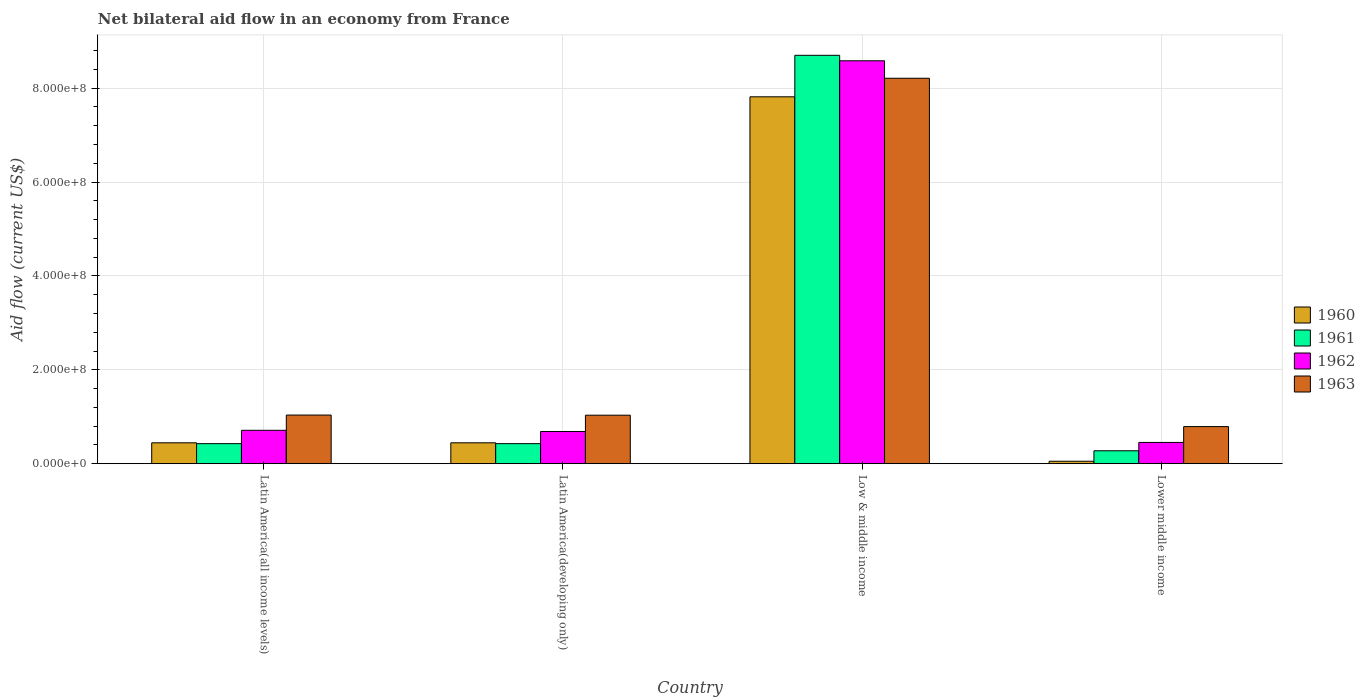How many groups of bars are there?
Provide a succinct answer. 4. Are the number of bars per tick equal to the number of legend labels?
Make the answer very short. Yes. Are the number of bars on each tick of the X-axis equal?
Offer a very short reply. Yes. How many bars are there on the 4th tick from the left?
Ensure brevity in your answer.  4. How many bars are there on the 4th tick from the right?
Your answer should be very brief. 4. What is the label of the 1st group of bars from the left?
Your answer should be very brief. Latin America(all income levels). What is the net bilateral aid flow in 1960 in Latin America(all income levels)?
Provide a short and direct response. 4.46e+07. Across all countries, what is the maximum net bilateral aid flow in 1960?
Your answer should be very brief. 7.82e+08. Across all countries, what is the minimum net bilateral aid flow in 1960?
Give a very brief answer. 5.30e+06. In which country was the net bilateral aid flow in 1961 maximum?
Offer a very short reply. Low & middle income. In which country was the net bilateral aid flow in 1963 minimum?
Your answer should be very brief. Lower middle income. What is the total net bilateral aid flow in 1962 in the graph?
Your answer should be very brief. 1.04e+09. What is the difference between the net bilateral aid flow in 1961 in Latin America(all income levels) and that in Latin America(developing only)?
Give a very brief answer. 0. What is the difference between the net bilateral aid flow in 1961 in Latin America(all income levels) and the net bilateral aid flow in 1960 in Lower middle income?
Your response must be concise. 3.75e+07. What is the average net bilateral aid flow in 1960 per country?
Offer a very short reply. 2.19e+08. What is the difference between the net bilateral aid flow of/in 1963 and net bilateral aid flow of/in 1961 in Low & middle income?
Keep it short and to the point. -4.89e+07. What is the ratio of the net bilateral aid flow in 1960 in Low & middle income to that in Lower middle income?
Your answer should be compact. 147.47. Is the net bilateral aid flow in 1962 in Latin America(developing only) less than that in Lower middle income?
Provide a short and direct response. No. Is the difference between the net bilateral aid flow in 1963 in Latin America(all income levels) and Lower middle income greater than the difference between the net bilateral aid flow in 1961 in Latin America(all income levels) and Lower middle income?
Your answer should be very brief. Yes. What is the difference between the highest and the second highest net bilateral aid flow in 1960?
Provide a short and direct response. 7.37e+08. What is the difference between the highest and the lowest net bilateral aid flow in 1963?
Give a very brief answer. 7.42e+08. Is the sum of the net bilateral aid flow in 1962 in Low & middle income and Lower middle income greater than the maximum net bilateral aid flow in 1963 across all countries?
Provide a short and direct response. Yes. Is it the case that in every country, the sum of the net bilateral aid flow in 1961 and net bilateral aid flow in 1963 is greater than the sum of net bilateral aid flow in 1960 and net bilateral aid flow in 1962?
Provide a short and direct response. Yes. What does the 4th bar from the left in Lower middle income represents?
Offer a very short reply. 1963. What does the 1st bar from the right in Low & middle income represents?
Your response must be concise. 1963. How many bars are there?
Provide a short and direct response. 16. How many countries are there in the graph?
Ensure brevity in your answer.  4. Are the values on the major ticks of Y-axis written in scientific E-notation?
Provide a short and direct response. Yes. Where does the legend appear in the graph?
Ensure brevity in your answer.  Center right. How many legend labels are there?
Your response must be concise. 4. What is the title of the graph?
Your response must be concise. Net bilateral aid flow in an economy from France. What is the label or title of the X-axis?
Keep it short and to the point. Country. What is the Aid flow (current US$) in 1960 in Latin America(all income levels)?
Your response must be concise. 4.46e+07. What is the Aid flow (current US$) of 1961 in Latin America(all income levels)?
Offer a terse response. 4.28e+07. What is the Aid flow (current US$) of 1962 in Latin America(all income levels)?
Your response must be concise. 7.12e+07. What is the Aid flow (current US$) of 1963 in Latin America(all income levels)?
Offer a very short reply. 1.04e+08. What is the Aid flow (current US$) of 1960 in Latin America(developing only)?
Keep it short and to the point. 4.46e+07. What is the Aid flow (current US$) in 1961 in Latin America(developing only)?
Provide a short and direct response. 4.28e+07. What is the Aid flow (current US$) in 1962 in Latin America(developing only)?
Give a very brief answer. 6.87e+07. What is the Aid flow (current US$) in 1963 in Latin America(developing only)?
Give a very brief answer. 1.03e+08. What is the Aid flow (current US$) of 1960 in Low & middle income?
Your answer should be very brief. 7.82e+08. What is the Aid flow (current US$) in 1961 in Low & middle income?
Offer a terse response. 8.70e+08. What is the Aid flow (current US$) of 1962 in Low & middle income?
Give a very brief answer. 8.58e+08. What is the Aid flow (current US$) in 1963 in Low & middle income?
Offer a terse response. 8.21e+08. What is the Aid flow (current US$) of 1960 in Lower middle income?
Offer a very short reply. 5.30e+06. What is the Aid flow (current US$) in 1961 in Lower middle income?
Provide a succinct answer. 2.76e+07. What is the Aid flow (current US$) in 1962 in Lower middle income?
Your response must be concise. 4.54e+07. What is the Aid flow (current US$) in 1963 in Lower middle income?
Your answer should be very brief. 7.91e+07. Across all countries, what is the maximum Aid flow (current US$) of 1960?
Keep it short and to the point. 7.82e+08. Across all countries, what is the maximum Aid flow (current US$) in 1961?
Provide a succinct answer. 8.70e+08. Across all countries, what is the maximum Aid flow (current US$) of 1962?
Ensure brevity in your answer.  8.58e+08. Across all countries, what is the maximum Aid flow (current US$) in 1963?
Keep it short and to the point. 8.21e+08. Across all countries, what is the minimum Aid flow (current US$) of 1960?
Offer a terse response. 5.30e+06. Across all countries, what is the minimum Aid flow (current US$) in 1961?
Ensure brevity in your answer.  2.76e+07. Across all countries, what is the minimum Aid flow (current US$) of 1962?
Your answer should be very brief. 4.54e+07. Across all countries, what is the minimum Aid flow (current US$) of 1963?
Your response must be concise. 7.91e+07. What is the total Aid flow (current US$) of 1960 in the graph?
Make the answer very short. 8.76e+08. What is the total Aid flow (current US$) in 1961 in the graph?
Ensure brevity in your answer.  9.83e+08. What is the total Aid flow (current US$) of 1962 in the graph?
Your answer should be very brief. 1.04e+09. What is the total Aid flow (current US$) in 1963 in the graph?
Your answer should be compact. 1.11e+09. What is the difference between the Aid flow (current US$) of 1962 in Latin America(all income levels) and that in Latin America(developing only)?
Offer a terse response. 2.50e+06. What is the difference between the Aid flow (current US$) of 1963 in Latin America(all income levels) and that in Latin America(developing only)?
Ensure brevity in your answer.  3.00e+05. What is the difference between the Aid flow (current US$) of 1960 in Latin America(all income levels) and that in Low & middle income?
Provide a succinct answer. -7.37e+08. What is the difference between the Aid flow (current US$) of 1961 in Latin America(all income levels) and that in Low & middle income?
Give a very brief answer. -8.27e+08. What is the difference between the Aid flow (current US$) of 1962 in Latin America(all income levels) and that in Low & middle income?
Offer a terse response. -7.87e+08. What is the difference between the Aid flow (current US$) in 1963 in Latin America(all income levels) and that in Low & middle income?
Ensure brevity in your answer.  -7.17e+08. What is the difference between the Aid flow (current US$) of 1960 in Latin America(all income levels) and that in Lower middle income?
Provide a short and direct response. 3.93e+07. What is the difference between the Aid flow (current US$) in 1961 in Latin America(all income levels) and that in Lower middle income?
Ensure brevity in your answer.  1.52e+07. What is the difference between the Aid flow (current US$) in 1962 in Latin America(all income levels) and that in Lower middle income?
Offer a very short reply. 2.58e+07. What is the difference between the Aid flow (current US$) in 1963 in Latin America(all income levels) and that in Lower middle income?
Offer a terse response. 2.46e+07. What is the difference between the Aid flow (current US$) in 1960 in Latin America(developing only) and that in Low & middle income?
Give a very brief answer. -7.37e+08. What is the difference between the Aid flow (current US$) in 1961 in Latin America(developing only) and that in Low & middle income?
Offer a terse response. -8.27e+08. What is the difference between the Aid flow (current US$) in 1962 in Latin America(developing only) and that in Low & middle income?
Make the answer very short. -7.90e+08. What is the difference between the Aid flow (current US$) in 1963 in Latin America(developing only) and that in Low & middle income?
Keep it short and to the point. -7.18e+08. What is the difference between the Aid flow (current US$) of 1960 in Latin America(developing only) and that in Lower middle income?
Give a very brief answer. 3.93e+07. What is the difference between the Aid flow (current US$) in 1961 in Latin America(developing only) and that in Lower middle income?
Ensure brevity in your answer.  1.52e+07. What is the difference between the Aid flow (current US$) of 1962 in Latin America(developing only) and that in Lower middle income?
Your answer should be very brief. 2.33e+07. What is the difference between the Aid flow (current US$) in 1963 in Latin America(developing only) and that in Lower middle income?
Your response must be concise. 2.43e+07. What is the difference between the Aid flow (current US$) in 1960 in Low & middle income and that in Lower middle income?
Make the answer very short. 7.76e+08. What is the difference between the Aid flow (current US$) in 1961 in Low & middle income and that in Lower middle income?
Give a very brief answer. 8.42e+08. What is the difference between the Aid flow (current US$) of 1962 in Low & middle income and that in Lower middle income?
Give a very brief answer. 8.13e+08. What is the difference between the Aid flow (current US$) of 1963 in Low & middle income and that in Lower middle income?
Keep it short and to the point. 7.42e+08. What is the difference between the Aid flow (current US$) of 1960 in Latin America(all income levels) and the Aid flow (current US$) of 1961 in Latin America(developing only)?
Your answer should be compact. 1.80e+06. What is the difference between the Aid flow (current US$) of 1960 in Latin America(all income levels) and the Aid flow (current US$) of 1962 in Latin America(developing only)?
Give a very brief answer. -2.41e+07. What is the difference between the Aid flow (current US$) in 1960 in Latin America(all income levels) and the Aid flow (current US$) in 1963 in Latin America(developing only)?
Make the answer very short. -5.88e+07. What is the difference between the Aid flow (current US$) of 1961 in Latin America(all income levels) and the Aid flow (current US$) of 1962 in Latin America(developing only)?
Your answer should be very brief. -2.59e+07. What is the difference between the Aid flow (current US$) of 1961 in Latin America(all income levels) and the Aid flow (current US$) of 1963 in Latin America(developing only)?
Keep it short and to the point. -6.06e+07. What is the difference between the Aid flow (current US$) in 1962 in Latin America(all income levels) and the Aid flow (current US$) in 1963 in Latin America(developing only)?
Your answer should be very brief. -3.22e+07. What is the difference between the Aid flow (current US$) of 1960 in Latin America(all income levels) and the Aid flow (current US$) of 1961 in Low & middle income?
Ensure brevity in your answer.  -8.25e+08. What is the difference between the Aid flow (current US$) in 1960 in Latin America(all income levels) and the Aid flow (current US$) in 1962 in Low & middle income?
Offer a terse response. -8.14e+08. What is the difference between the Aid flow (current US$) of 1960 in Latin America(all income levels) and the Aid flow (current US$) of 1963 in Low & middle income?
Ensure brevity in your answer.  -7.76e+08. What is the difference between the Aid flow (current US$) of 1961 in Latin America(all income levels) and the Aid flow (current US$) of 1962 in Low & middle income?
Give a very brief answer. -8.16e+08. What is the difference between the Aid flow (current US$) in 1961 in Latin America(all income levels) and the Aid flow (current US$) in 1963 in Low & middle income?
Your response must be concise. -7.78e+08. What is the difference between the Aid flow (current US$) of 1962 in Latin America(all income levels) and the Aid flow (current US$) of 1963 in Low & middle income?
Your response must be concise. -7.50e+08. What is the difference between the Aid flow (current US$) of 1960 in Latin America(all income levels) and the Aid flow (current US$) of 1961 in Lower middle income?
Give a very brief answer. 1.70e+07. What is the difference between the Aid flow (current US$) in 1960 in Latin America(all income levels) and the Aid flow (current US$) in 1962 in Lower middle income?
Your answer should be compact. -8.00e+05. What is the difference between the Aid flow (current US$) in 1960 in Latin America(all income levels) and the Aid flow (current US$) in 1963 in Lower middle income?
Keep it short and to the point. -3.45e+07. What is the difference between the Aid flow (current US$) of 1961 in Latin America(all income levels) and the Aid flow (current US$) of 1962 in Lower middle income?
Make the answer very short. -2.60e+06. What is the difference between the Aid flow (current US$) in 1961 in Latin America(all income levels) and the Aid flow (current US$) in 1963 in Lower middle income?
Your response must be concise. -3.63e+07. What is the difference between the Aid flow (current US$) of 1962 in Latin America(all income levels) and the Aid flow (current US$) of 1963 in Lower middle income?
Your answer should be compact. -7.90e+06. What is the difference between the Aid flow (current US$) in 1960 in Latin America(developing only) and the Aid flow (current US$) in 1961 in Low & middle income?
Your answer should be very brief. -8.25e+08. What is the difference between the Aid flow (current US$) in 1960 in Latin America(developing only) and the Aid flow (current US$) in 1962 in Low & middle income?
Provide a succinct answer. -8.14e+08. What is the difference between the Aid flow (current US$) in 1960 in Latin America(developing only) and the Aid flow (current US$) in 1963 in Low & middle income?
Your answer should be very brief. -7.76e+08. What is the difference between the Aid flow (current US$) in 1961 in Latin America(developing only) and the Aid flow (current US$) in 1962 in Low & middle income?
Offer a very short reply. -8.16e+08. What is the difference between the Aid flow (current US$) of 1961 in Latin America(developing only) and the Aid flow (current US$) of 1963 in Low & middle income?
Your answer should be very brief. -7.78e+08. What is the difference between the Aid flow (current US$) of 1962 in Latin America(developing only) and the Aid flow (current US$) of 1963 in Low & middle income?
Keep it short and to the point. -7.52e+08. What is the difference between the Aid flow (current US$) in 1960 in Latin America(developing only) and the Aid flow (current US$) in 1961 in Lower middle income?
Keep it short and to the point. 1.70e+07. What is the difference between the Aid flow (current US$) in 1960 in Latin America(developing only) and the Aid flow (current US$) in 1962 in Lower middle income?
Your answer should be very brief. -8.00e+05. What is the difference between the Aid flow (current US$) in 1960 in Latin America(developing only) and the Aid flow (current US$) in 1963 in Lower middle income?
Provide a succinct answer. -3.45e+07. What is the difference between the Aid flow (current US$) in 1961 in Latin America(developing only) and the Aid flow (current US$) in 1962 in Lower middle income?
Your response must be concise. -2.60e+06. What is the difference between the Aid flow (current US$) in 1961 in Latin America(developing only) and the Aid flow (current US$) in 1963 in Lower middle income?
Your answer should be very brief. -3.63e+07. What is the difference between the Aid flow (current US$) in 1962 in Latin America(developing only) and the Aid flow (current US$) in 1963 in Lower middle income?
Give a very brief answer. -1.04e+07. What is the difference between the Aid flow (current US$) of 1960 in Low & middle income and the Aid flow (current US$) of 1961 in Lower middle income?
Make the answer very short. 7.54e+08. What is the difference between the Aid flow (current US$) in 1960 in Low & middle income and the Aid flow (current US$) in 1962 in Lower middle income?
Give a very brief answer. 7.36e+08. What is the difference between the Aid flow (current US$) of 1960 in Low & middle income and the Aid flow (current US$) of 1963 in Lower middle income?
Keep it short and to the point. 7.02e+08. What is the difference between the Aid flow (current US$) of 1961 in Low & middle income and the Aid flow (current US$) of 1962 in Lower middle income?
Offer a very short reply. 8.25e+08. What is the difference between the Aid flow (current US$) in 1961 in Low & middle income and the Aid flow (current US$) in 1963 in Lower middle income?
Provide a short and direct response. 7.91e+08. What is the difference between the Aid flow (current US$) in 1962 in Low & middle income and the Aid flow (current US$) in 1963 in Lower middle income?
Ensure brevity in your answer.  7.79e+08. What is the average Aid flow (current US$) of 1960 per country?
Make the answer very short. 2.19e+08. What is the average Aid flow (current US$) of 1961 per country?
Give a very brief answer. 2.46e+08. What is the average Aid flow (current US$) in 1962 per country?
Your response must be concise. 2.61e+08. What is the average Aid flow (current US$) in 1963 per country?
Offer a terse response. 2.77e+08. What is the difference between the Aid flow (current US$) of 1960 and Aid flow (current US$) of 1961 in Latin America(all income levels)?
Your response must be concise. 1.80e+06. What is the difference between the Aid flow (current US$) in 1960 and Aid flow (current US$) in 1962 in Latin America(all income levels)?
Give a very brief answer. -2.66e+07. What is the difference between the Aid flow (current US$) in 1960 and Aid flow (current US$) in 1963 in Latin America(all income levels)?
Provide a short and direct response. -5.91e+07. What is the difference between the Aid flow (current US$) in 1961 and Aid flow (current US$) in 1962 in Latin America(all income levels)?
Give a very brief answer. -2.84e+07. What is the difference between the Aid flow (current US$) in 1961 and Aid flow (current US$) in 1963 in Latin America(all income levels)?
Make the answer very short. -6.09e+07. What is the difference between the Aid flow (current US$) of 1962 and Aid flow (current US$) of 1963 in Latin America(all income levels)?
Offer a very short reply. -3.25e+07. What is the difference between the Aid flow (current US$) in 1960 and Aid flow (current US$) in 1961 in Latin America(developing only)?
Provide a short and direct response. 1.80e+06. What is the difference between the Aid flow (current US$) in 1960 and Aid flow (current US$) in 1962 in Latin America(developing only)?
Ensure brevity in your answer.  -2.41e+07. What is the difference between the Aid flow (current US$) in 1960 and Aid flow (current US$) in 1963 in Latin America(developing only)?
Provide a short and direct response. -5.88e+07. What is the difference between the Aid flow (current US$) of 1961 and Aid flow (current US$) of 1962 in Latin America(developing only)?
Make the answer very short. -2.59e+07. What is the difference between the Aid flow (current US$) in 1961 and Aid flow (current US$) in 1963 in Latin America(developing only)?
Make the answer very short. -6.06e+07. What is the difference between the Aid flow (current US$) in 1962 and Aid flow (current US$) in 1963 in Latin America(developing only)?
Offer a very short reply. -3.47e+07. What is the difference between the Aid flow (current US$) of 1960 and Aid flow (current US$) of 1961 in Low & middle income?
Offer a terse response. -8.84e+07. What is the difference between the Aid flow (current US$) of 1960 and Aid flow (current US$) of 1962 in Low & middle income?
Provide a short and direct response. -7.67e+07. What is the difference between the Aid flow (current US$) in 1960 and Aid flow (current US$) in 1963 in Low & middle income?
Give a very brief answer. -3.95e+07. What is the difference between the Aid flow (current US$) of 1961 and Aid flow (current US$) of 1962 in Low & middle income?
Give a very brief answer. 1.17e+07. What is the difference between the Aid flow (current US$) of 1961 and Aid flow (current US$) of 1963 in Low & middle income?
Keep it short and to the point. 4.89e+07. What is the difference between the Aid flow (current US$) in 1962 and Aid flow (current US$) in 1963 in Low & middle income?
Your answer should be very brief. 3.72e+07. What is the difference between the Aid flow (current US$) of 1960 and Aid flow (current US$) of 1961 in Lower middle income?
Your response must be concise. -2.23e+07. What is the difference between the Aid flow (current US$) of 1960 and Aid flow (current US$) of 1962 in Lower middle income?
Give a very brief answer. -4.01e+07. What is the difference between the Aid flow (current US$) in 1960 and Aid flow (current US$) in 1963 in Lower middle income?
Ensure brevity in your answer.  -7.38e+07. What is the difference between the Aid flow (current US$) of 1961 and Aid flow (current US$) of 1962 in Lower middle income?
Offer a terse response. -1.78e+07. What is the difference between the Aid flow (current US$) in 1961 and Aid flow (current US$) in 1963 in Lower middle income?
Keep it short and to the point. -5.15e+07. What is the difference between the Aid flow (current US$) in 1962 and Aid flow (current US$) in 1963 in Lower middle income?
Make the answer very short. -3.37e+07. What is the ratio of the Aid flow (current US$) in 1960 in Latin America(all income levels) to that in Latin America(developing only)?
Keep it short and to the point. 1. What is the ratio of the Aid flow (current US$) of 1961 in Latin America(all income levels) to that in Latin America(developing only)?
Offer a very short reply. 1. What is the ratio of the Aid flow (current US$) in 1962 in Latin America(all income levels) to that in Latin America(developing only)?
Provide a succinct answer. 1.04. What is the ratio of the Aid flow (current US$) of 1963 in Latin America(all income levels) to that in Latin America(developing only)?
Ensure brevity in your answer.  1. What is the ratio of the Aid flow (current US$) of 1960 in Latin America(all income levels) to that in Low & middle income?
Provide a short and direct response. 0.06. What is the ratio of the Aid flow (current US$) of 1961 in Latin America(all income levels) to that in Low & middle income?
Provide a short and direct response. 0.05. What is the ratio of the Aid flow (current US$) in 1962 in Latin America(all income levels) to that in Low & middle income?
Give a very brief answer. 0.08. What is the ratio of the Aid flow (current US$) of 1963 in Latin America(all income levels) to that in Low & middle income?
Ensure brevity in your answer.  0.13. What is the ratio of the Aid flow (current US$) of 1960 in Latin America(all income levels) to that in Lower middle income?
Make the answer very short. 8.42. What is the ratio of the Aid flow (current US$) in 1961 in Latin America(all income levels) to that in Lower middle income?
Offer a very short reply. 1.55. What is the ratio of the Aid flow (current US$) of 1962 in Latin America(all income levels) to that in Lower middle income?
Give a very brief answer. 1.57. What is the ratio of the Aid flow (current US$) in 1963 in Latin America(all income levels) to that in Lower middle income?
Keep it short and to the point. 1.31. What is the ratio of the Aid flow (current US$) in 1960 in Latin America(developing only) to that in Low & middle income?
Ensure brevity in your answer.  0.06. What is the ratio of the Aid flow (current US$) of 1961 in Latin America(developing only) to that in Low & middle income?
Offer a terse response. 0.05. What is the ratio of the Aid flow (current US$) in 1963 in Latin America(developing only) to that in Low & middle income?
Keep it short and to the point. 0.13. What is the ratio of the Aid flow (current US$) in 1960 in Latin America(developing only) to that in Lower middle income?
Make the answer very short. 8.42. What is the ratio of the Aid flow (current US$) of 1961 in Latin America(developing only) to that in Lower middle income?
Ensure brevity in your answer.  1.55. What is the ratio of the Aid flow (current US$) of 1962 in Latin America(developing only) to that in Lower middle income?
Provide a short and direct response. 1.51. What is the ratio of the Aid flow (current US$) in 1963 in Latin America(developing only) to that in Lower middle income?
Your response must be concise. 1.31. What is the ratio of the Aid flow (current US$) of 1960 in Low & middle income to that in Lower middle income?
Keep it short and to the point. 147.47. What is the ratio of the Aid flow (current US$) of 1961 in Low & middle income to that in Lower middle income?
Make the answer very short. 31.52. What is the ratio of the Aid flow (current US$) of 1962 in Low & middle income to that in Lower middle income?
Provide a succinct answer. 18.91. What is the ratio of the Aid flow (current US$) in 1963 in Low & middle income to that in Lower middle income?
Give a very brief answer. 10.38. What is the difference between the highest and the second highest Aid flow (current US$) of 1960?
Your response must be concise. 7.37e+08. What is the difference between the highest and the second highest Aid flow (current US$) in 1961?
Offer a very short reply. 8.27e+08. What is the difference between the highest and the second highest Aid flow (current US$) in 1962?
Your answer should be very brief. 7.87e+08. What is the difference between the highest and the second highest Aid flow (current US$) in 1963?
Your answer should be very brief. 7.17e+08. What is the difference between the highest and the lowest Aid flow (current US$) in 1960?
Keep it short and to the point. 7.76e+08. What is the difference between the highest and the lowest Aid flow (current US$) in 1961?
Give a very brief answer. 8.42e+08. What is the difference between the highest and the lowest Aid flow (current US$) of 1962?
Your answer should be compact. 8.13e+08. What is the difference between the highest and the lowest Aid flow (current US$) of 1963?
Provide a succinct answer. 7.42e+08. 